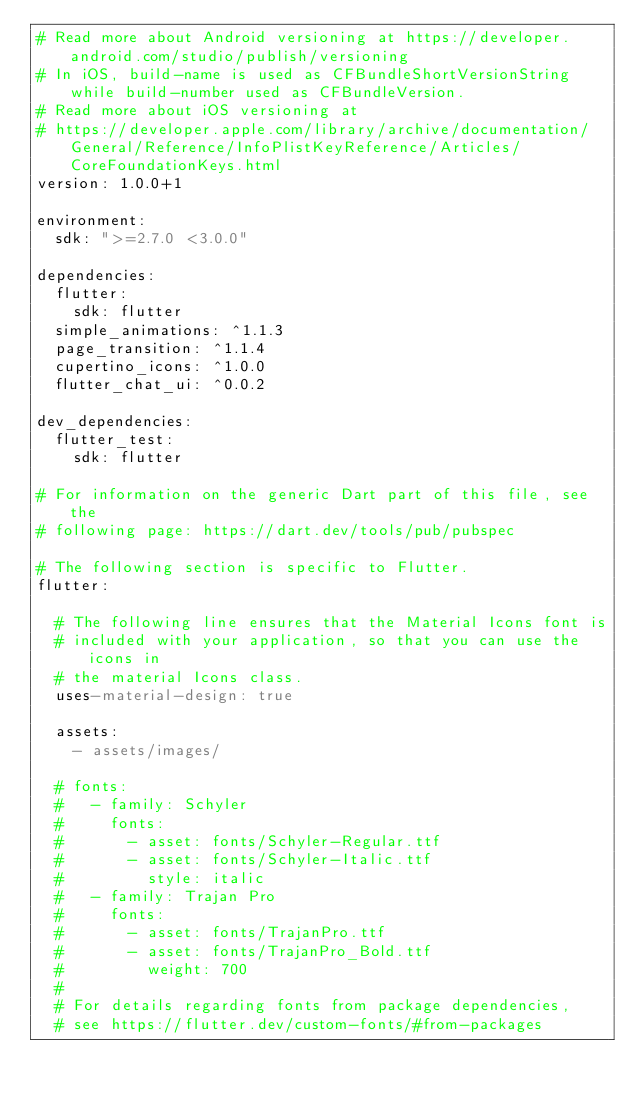Convert code to text. <code><loc_0><loc_0><loc_500><loc_500><_YAML_># Read more about Android versioning at https://developer.android.com/studio/publish/versioning
# In iOS, build-name is used as CFBundleShortVersionString while build-number used as CFBundleVersion.
# Read more about iOS versioning at
# https://developer.apple.com/library/archive/documentation/General/Reference/InfoPlistKeyReference/Articles/CoreFoundationKeys.html
version: 1.0.0+1

environment:
  sdk: ">=2.7.0 <3.0.0"

dependencies:
  flutter:
    sdk: flutter
  simple_animations: ^1.1.3
  page_transition: ^1.1.4
  cupertino_icons: ^1.0.0
  flutter_chat_ui: ^0.0.2

dev_dependencies:
  flutter_test:
    sdk: flutter

# For information on the generic Dart part of this file, see the
# following page: https://dart.dev/tools/pub/pubspec

# The following section is specific to Flutter.
flutter:

  # The following line ensures that the Material Icons font is
  # included with your application, so that you can use the icons in
  # the material Icons class.
  uses-material-design: true

  assets:
    - assets/images/

  # fonts:
  #   - family: Schyler
  #     fonts:
  #       - asset: fonts/Schyler-Regular.ttf
  #       - asset: fonts/Schyler-Italic.ttf
  #         style: italic
  #   - family: Trajan Pro
  #     fonts:
  #       - asset: fonts/TrajanPro.ttf
  #       - asset: fonts/TrajanPro_Bold.ttf
  #         weight: 700
  #
  # For details regarding fonts from package dependencies,
  # see https://flutter.dev/custom-fonts/#from-packages
</code> 